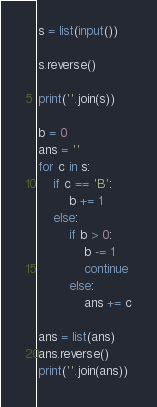Convert code to text. <code><loc_0><loc_0><loc_500><loc_500><_Python_>s = list(input())

s.reverse()

print(''.join(s))

b = 0
ans = ''
for c in s:
    if c == 'B':
        b += 1
    else:
        if b > 0:
            b -= 1
            continue
        else:
            ans += c

ans = list(ans)
ans.reverse()
print(''.join(ans))

</code> 